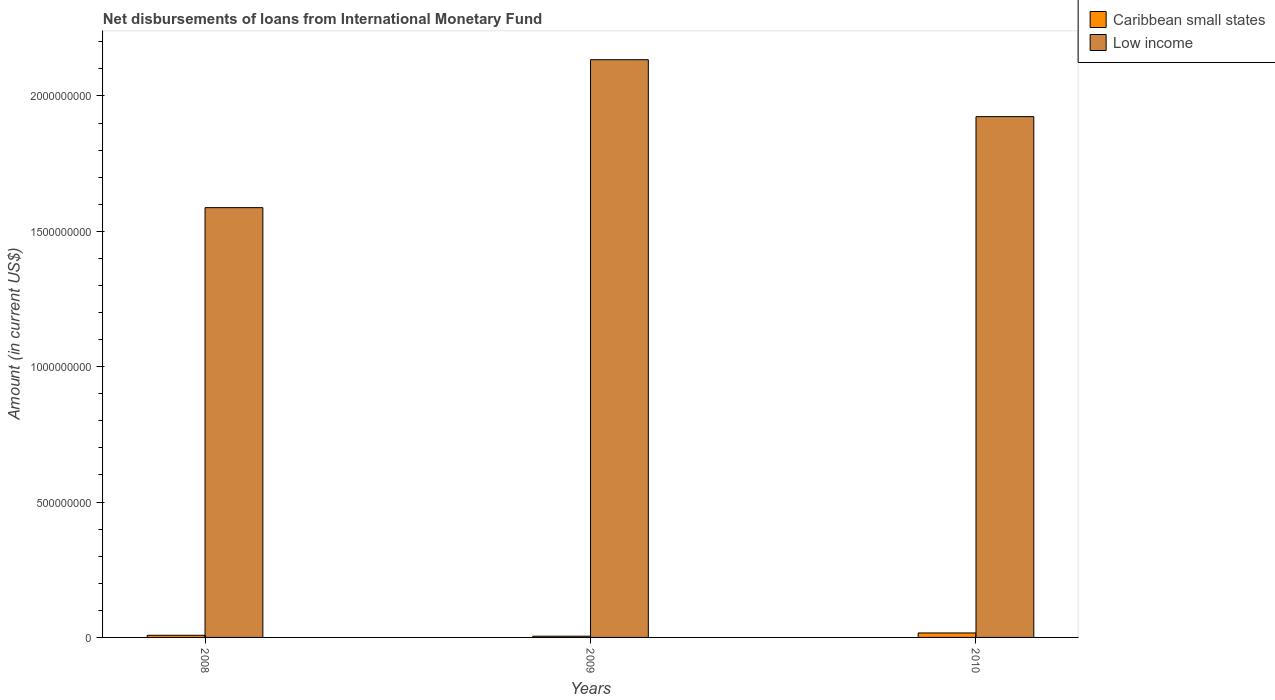How many groups of bars are there?
Offer a very short reply. 3. How many bars are there on the 1st tick from the left?
Offer a terse response. 2. How many bars are there on the 3rd tick from the right?
Give a very brief answer. 2. In how many cases, is the number of bars for a given year not equal to the number of legend labels?
Your answer should be very brief. 0. What is the amount of loans disbursed in Caribbean small states in 2009?
Your answer should be compact. 4.57e+06. Across all years, what is the maximum amount of loans disbursed in Caribbean small states?
Your response must be concise. 1.65e+07. Across all years, what is the minimum amount of loans disbursed in Low income?
Your answer should be very brief. 1.59e+09. In which year was the amount of loans disbursed in Low income maximum?
Make the answer very short. 2009. What is the total amount of loans disbursed in Caribbean small states in the graph?
Your answer should be very brief. 2.90e+07. What is the difference between the amount of loans disbursed in Low income in 2009 and that in 2010?
Give a very brief answer. 2.10e+08. What is the difference between the amount of loans disbursed in Caribbean small states in 2008 and the amount of loans disbursed in Low income in 2009?
Keep it short and to the point. -2.13e+09. What is the average amount of loans disbursed in Caribbean small states per year?
Your response must be concise. 9.68e+06. In the year 2008, what is the difference between the amount of loans disbursed in Caribbean small states and amount of loans disbursed in Low income?
Your response must be concise. -1.58e+09. In how many years, is the amount of loans disbursed in Low income greater than 1000000000 US$?
Offer a very short reply. 3. What is the ratio of the amount of loans disbursed in Low income in 2008 to that in 2009?
Keep it short and to the point. 0.74. What is the difference between the highest and the second highest amount of loans disbursed in Low income?
Offer a very short reply. 2.10e+08. What is the difference between the highest and the lowest amount of loans disbursed in Caribbean small states?
Offer a terse response. 1.19e+07. In how many years, is the amount of loans disbursed in Low income greater than the average amount of loans disbursed in Low income taken over all years?
Offer a terse response. 2. What does the 1st bar from the right in 2010 represents?
Your answer should be compact. Low income. Are all the bars in the graph horizontal?
Make the answer very short. No. How many years are there in the graph?
Offer a very short reply. 3. Are the values on the major ticks of Y-axis written in scientific E-notation?
Provide a succinct answer. No. Does the graph contain any zero values?
Offer a very short reply. No. How many legend labels are there?
Give a very brief answer. 2. What is the title of the graph?
Offer a very short reply. Net disbursements of loans from International Monetary Fund. Does "Cambodia" appear as one of the legend labels in the graph?
Offer a very short reply. No. What is the label or title of the X-axis?
Your answer should be compact. Years. What is the label or title of the Y-axis?
Keep it short and to the point. Amount (in current US$). What is the Amount (in current US$) in Caribbean small states in 2008?
Give a very brief answer. 7.98e+06. What is the Amount (in current US$) in Low income in 2008?
Provide a short and direct response. 1.59e+09. What is the Amount (in current US$) of Caribbean small states in 2009?
Your answer should be very brief. 4.57e+06. What is the Amount (in current US$) in Low income in 2009?
Keep it short and to the point. 2.13e+09. What is the Amount (in current US$) in Caribbean small states in 2010?
Offer a terse response. 1.65e+07. What is the Amount (in current US$) of Low income in 2010?
Provide a succinct answer. 1.92e+09. Across all years, what is the maximum Amount (in current US$) of Caribbean small states?
Your answer should be compact. 1.65e+07. Across all years, what is the maximum Amount (in current US$) of Low income?
Offer a very short reply. 2.13e+09. Across all years, what is the minimum Amount (in current US$) in Caribbean small states?
Your response must be concise. 4.57e+06. Across all years, what is the minimum Amount (in current US$) of Low income?
Provide a short and direct response. 1.59e+09. What is the total Amount (in current US$) of Caribbean small states in the graph?
Provide a succinct answer. 2.90e+07. What is the total Amount (in current US$) of Low income in the graph?
Offer a very short reply. 5.64e+09. What is the difference between the Amount (in current US$) in Caribbean small states in 2008 and that in 2009?
Ensure brevity in your answer.  3.41e+06. What is the difference between the Amount (in current US$) in Low income in 2008 and that in 2009?
Offer a terse response. -5.46e+08. What is the difference between the Amount (in current US$) of Caribbean small states in 2008 and that in 2010?
Give a very brief answer. -8.53e+06. What is the difference between the Amount (in current US$) of Low income in 2008 and that in 2010?
Your response must be concise. -3.36e+08. What is the difference between the Amount (in current US$) in Caribbean small states in 2009 and that in 2010?
Provide a short and direct response. -1.19e+07. What is the difference between the Amount (in current US$) of Low income in 2009 and that in 2010?
Give a very brief answer. 2.10e+08. What is the difference between the Amount (in current US$) of Caribbean small states in 2008 and the Amount (in current US$) of Low income in 2009?
Offer a very short reply. -2.13e+09. What is the difference between the Amount (in current US$) of Caribbean small states in 2008 and the Amount (in current US$) of Low income in 2010?
Provide a succinct answer. -1.92e+09. What is the difference between the Amount (in current US$) in Caribbean small states in 2009 and the Amount (in current US$) in Low income in 2010?
Ensure brevity in your answer.  -1.92e+09. What is the average Amount (in current US$) of Caribbean small states per year?
Offer a very short reply. 9.68e+06. What is the average Amount (in current US$) in Low income per year?
Offer a very short reply. 1.88e+09. In the year 2008, what is the difference between the Amount (in current US$) in Caribbean small states and Amount (in current US$) in Low income?
Give a very brief answer. -1.58e+09. In the year 2009, what is the difference between the Amount (in current US$) in Caribbean small states and Amount (in current US$) in Low income?
Offer a terse response. -2.13e+09. In the year 2010, what is the difference between the Amount (in current US$) of Caribbean small states and Amount (in current US$) of Low income?
Your answer should be compact. -1.91e+09. What is the ratio of the Amount (in current US$) in Caribbean small states in 2008 to that in 2009?
Make the answer very short. 1.75. What is the ratio of the Amount (in current US$) in Low income in 2008 to that in 2009?
Ensure brevity in your answer.  0.74. What is the ratio of the Amount (in current US$) of Caribbean small states in 2008 to that in 2010?
Offer a terse response. 0.48. What is the ratio of the Amount (in current US$) in Low income in 2008 to that in 2010?
Provide a succinct answer. 0.83. What is the ratio of the Amount (in current US$) in Caribbean small states in 2009 to that in 2010?
Provide a short and direct response. 0.28. What is the ratio of the Amount (in current US$) of Low income in 2009 to that in 2010?
Offer a terse response. 1.11. What is the difference between the highest and the second highest Amount (in current US$) of Caribbean small states?
Offer a terse response. 8.53e+06. What is the difference between the highest and the second highest Amount (in current US$) of Low income?
Provide a succinct answer. 2.10e+08. What is the difference between the highest and the lowest Amount (in current US$) in Caribbean small states?
Ensure brevity in your answer.  1.19e+07. What is the difference between the highest and the lowest Amount (in current US$) in Low income?
Your response must be concise. 5.46e+08. 